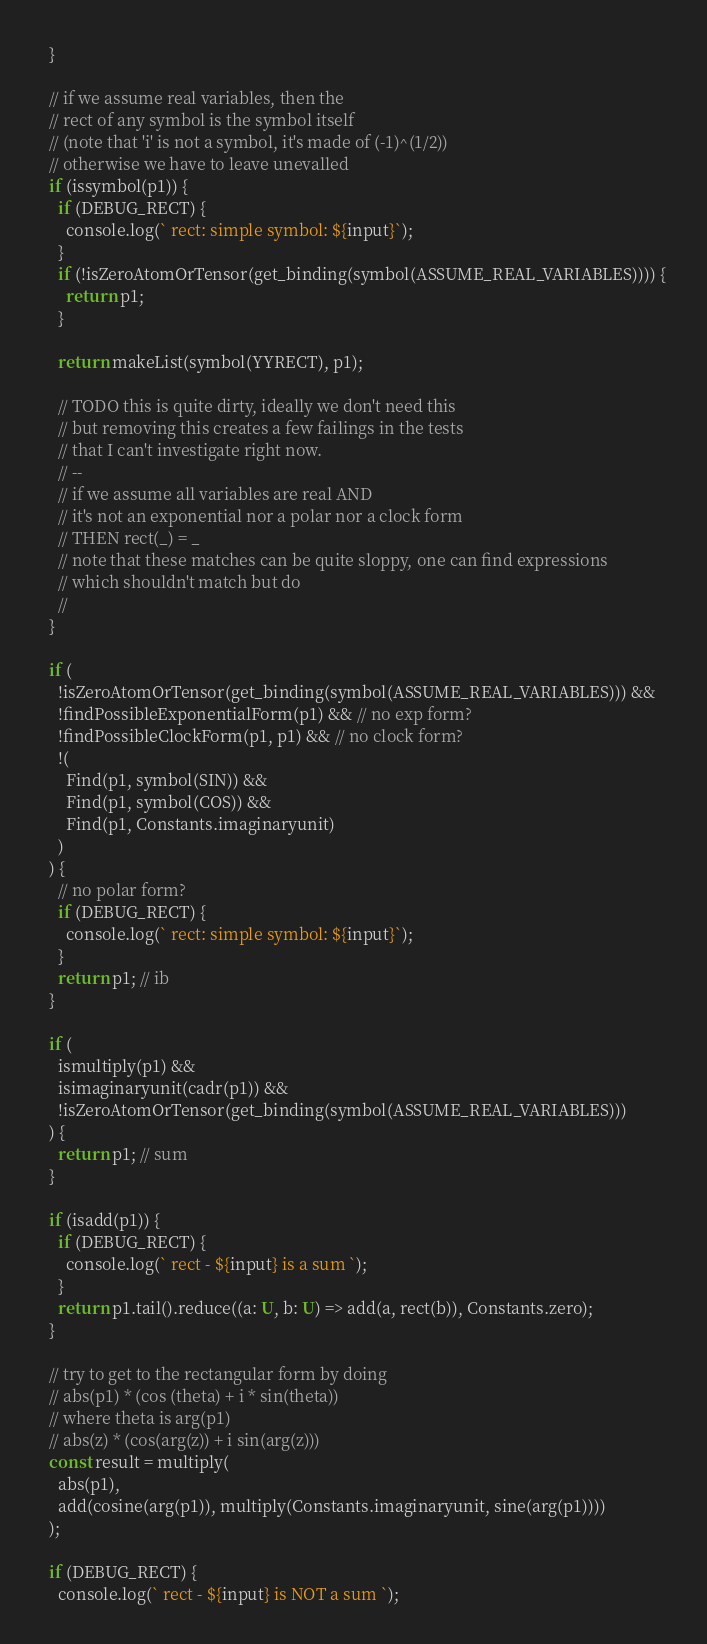<code> <loc_0><loc_0><loc_500><loc_500><_TypeScript_>  }

  // if we assume real variables, then the
  // rect of any symbol is the symbol itself
  // (note that 'i' is not a symbol, it's made of (-1)^(1/2))
  // otherwise we have to leave unevalled
  if (issymbol(p1)) {
    if (DEBUG_RECT) {
      console.log(` rect: simple symbol: ${input}`);
    }
    if (!isZeroAtomOrTensor(get_binding(symbol(ASSUME_REAL_VARIABLES)))) {
      return p1;
    }

    return makeList(symbol(YYRECT), p1);

    // TODO this is quite dirty, ideally we don't need this
    // but removing this creates a few failings in the tests
    // that I can't investigate right now.
    // --
    // if we assume all variables are real AND
    // it's not an exponential nor a polar nor a clock form
    // THEN rect(_) = _
    // note that these matches can be quite sloppy, one can find expressions
    // which shouldn't match but do
    //
  }

  if (
    !isZeroAtomOrTensor(get_binding(symbol(ASSUME_REAL_VARIABLES))) &&
    !findPossibleExponentialForm(p1) && // no exp form?
    !findPossibleClockForm(p1, p1) && // no clock form?
    !(
      Find(p1, symbol(SIN)) &&
      Find(p1, symbol(COS)) &&
      Find(p1, Constants.imaginaryunit)
    )
  ) {
    // no polar form?
    if (DEBUG_RECT) {
      console.log(` rect: simple symbol: ${input}`);
    }
    return p1; // ib
  }

  if (
    ismultiply(p1) &&
    isimaginaryunit(cadr(p1)) &&
    !isZeroAtomOrTensor(get_binding(symbol(ASSUME_REAL_VARIABLES)))
  ) {
    return p1; // sum
  }

  if (isadd(p1)) {
    if (DEBUG_RECT) {
      console.log(` rect - ${input} is a sum `);
    }
    return p1.tail().reduce((a: U, b: U) => add(a, rect(b)), Constants.zero);
  }

  // try to get to the rectangular form by doing
  // abs(p1) * (cos (theta) + i * sin(theta))
  // where theta is arg(p1)
  // abs(z) * (cos(arg(z)) + i sin(arg(z)))
  const result = multiply(
    abs(p1),
    add(cosine(arg(p1)), multiply(Constants.imaginaryunit, sine(arg(p1))))
  );

  if (DEBUG_RECT) {
    console.log(` rect - ${input} is NOT a sum `);</code> 